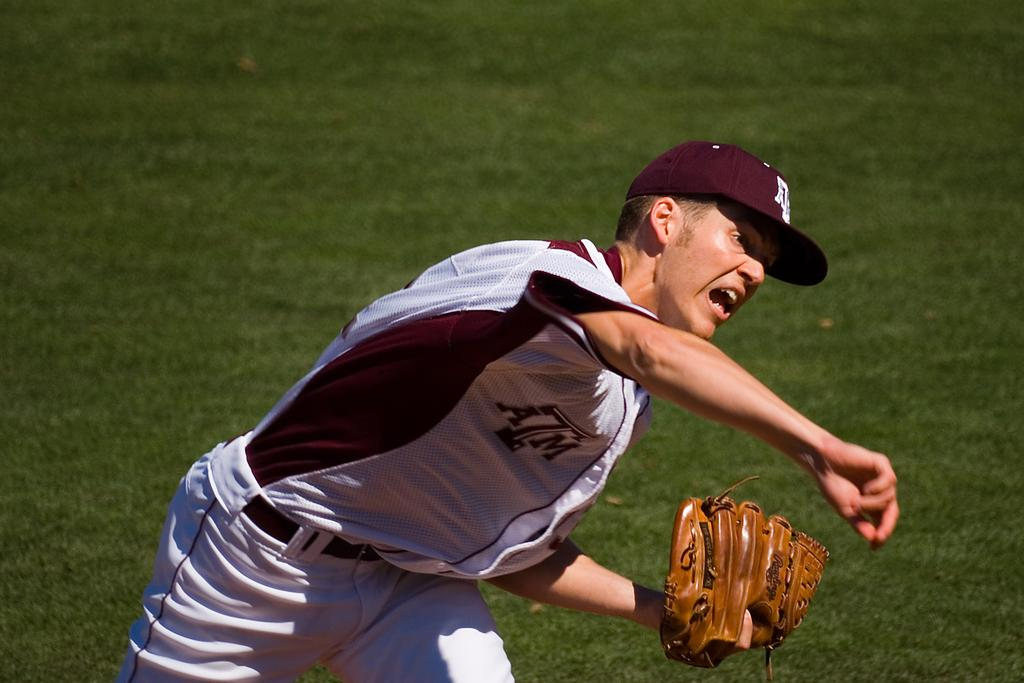<image>
Offer a succinct explanation of the picture presented. Man wearing a baseball jersey which says ATM throwing a ball. 